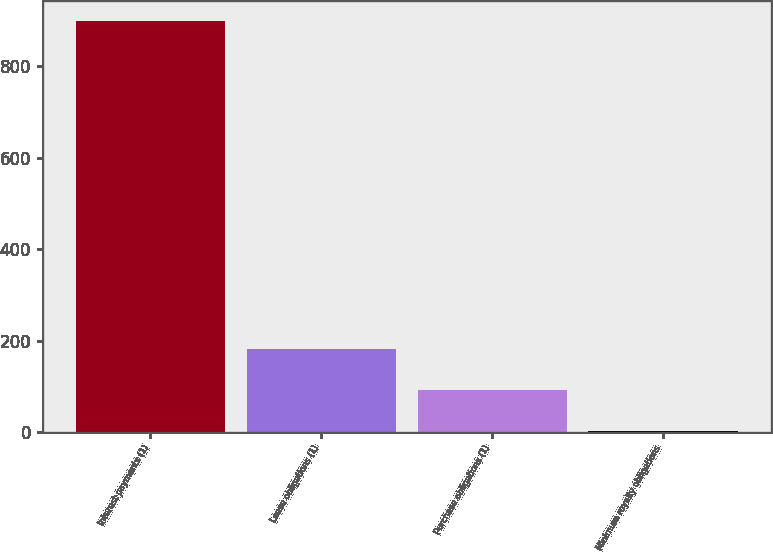Convert chart. <chart><loc_0><loc_0><loc_500><loc_500><bar_chart><fcel>Interest payments (1)<fcel>Lease obligations (1)<fcel>Purchase obligations (1)<fcel>Minimum royalty obligations<nl><fcel>899<fcel>180.6<fcel>90.8<fcel>1<nl></chart> 